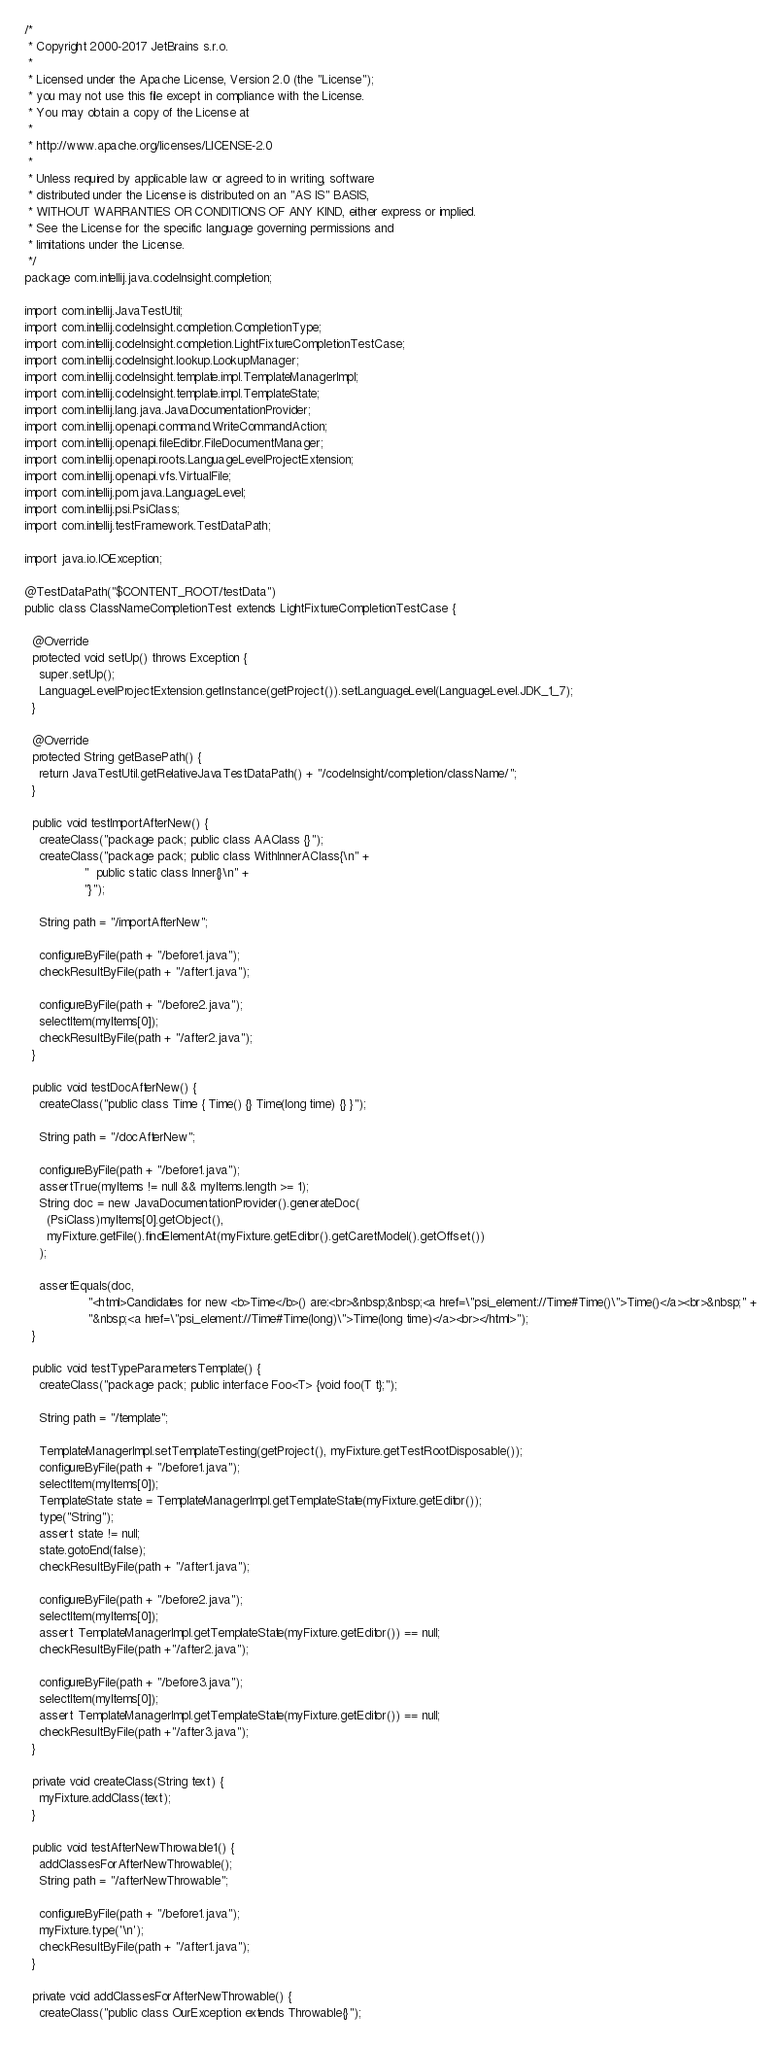<code> <loc_0><loc_0><loc_500><loc_500><_Java_>/*
 * Copyright 2000-2017 JetBrains s.r.o.
 *
 * Licensed under the Apache License, Version 2.0 (the "License");
 * you may not use this file except in compliance with the License.
 * You may obtain a copy of the License at
 *
 * http://www.apache.org/licenses/LICENSE-2.0
 *
 * Unless required by applicable law or agreed to in writing, software
 * distributed under the License is distributed on an "AS IS" BASIS,
 * WITHOUT WARRANTIES OR CONDITIONS OF ANY KIND, either express or implied.
 * See the License for the specific language governing permissions and
 * limitations under the License.
 */
package com.intellij.java.codeInsight.completion;

import com.intellij.JavaTestUtil;
import com.intellij.codeInsight.completion.CompletionType;
import com.intellij.codeInsight.completion.LightFixtureCompletionTestCase;
import com.intellij.codeInsight.lookup.LookupManager;
import com.intellij.codeInsight.template.impl.TemplateManagerImpl;
import com.intellij.codeInsight.template.impl.TemplateState;
import com.intellij.lang.java.JavaDocumentationProvider;
import com.intellij.openapi.command.WriteCommandAction;
import com.intellij.openapi.fileEditor.FileDocumentManager;
import com.intellij.openapi.roots.LanguageLevelProjectExtension;
import com.intellij.openapi.vfs.VirtualFile;
import com.intellij.pom.java.LanguageLevel;
import com.intellij.psi.PsiClass;
import com.intellij.testFramework.TestDataPath;

import java.io.IOException;

@TestDataPath("$CONTENT_ROOT/testData")
public class ClassNameCompletionTest extends LightFixtureCompletionTestCase {

  @Override
  protected void setUp() throws Exception {
    super.setUp();
    LanguageLevelProjectExtension.getInstance(getProject()).setLanguageLevel(LanguageLevel.JDK_1_7);
  }

  @Override
  protected String getBasePath() {
    return JavaTestUtil.getRelativeJavaTestDataPath() + "/codeInsight/completion/className/";
  }

  public void testImportAfterNew() {
    createClass("package pack; public class AAClass {}");
    createClass("package pack; public class WithInnerAClass{\n" +
                "  public static class Inner{}\n" +
                "}");

    String path = "/importAfterNew";

    configureByFile(path + "/before1.java");
    checkResultByFile(path + "/after1.java");

    configureByFile(path + "/before2.java");
    selectItem(myItems[0]);
    checkResultByFile(path + "/after2.java");
  }

  public void testDocAfterNew() {
    createClass("public class Time { Time() {} Time(long time) {} }");

    String path = "/docAfterNew";

    configureByFile(path + "/before1.java");
    assertTrue(myItems != null && myItems.length >= 1);
    String doc = new JavaDocumentationProvider().generateDoc(
      (PsiClass)myItems[0].getObject(),
      myFixture.getFile().findElementAt(myFixture.getEditor().getCaretModel().getOffset())
    );

    assertEquals(doc,
                 "<html>Candidates for new <b>Time</b>() are:<br>&nbsp;&nbsp;<a href=\"psi_element://Time#Time()\">Time()</a><br>&nbsp;" +
                 "&nbsp;<a href=\"psi_element://Time#Time(long)\">Time(long time)</a><br></html>");
  }

  public void testTypeParametersTemplate() {
    createClass("package pack; public interface Foo<T> {void foo(T t};");

    String path = "/template";

    TemplateManagerImpl.setTemplateTesting(getProject(), myFixture.getTestRootDisposable());
    configureByFile(path + "/before1.java");
    selectItem(myItems[0]);
    TemplateState state = TemplateManagerImpl.getTemplateState(myFixture.getEditor());
    type("String");
    assert state != null;
    state.gotoEnd(false);
    checkResultByFile(path + "/after1.java");

    configureByFile(path + "/before2.java");
    selectItem(myItems[0]);
    assert TemplateManagerImpl.getTemplateState(myFixture.getEditor()) == null;
    checkResultByFile(path +"/after2.java");

    configureByFile(path + "/before3.java");
    selectItem(myItems[0]);
    assert TemplateManagerImpl.getTemplateState(myFixture.getEditor()) == null;
    checkResultByFile(path +"/after3.java");
  }

  private void createClass(String text) {
    myFixture.addClass(text);
  }

  public void testAfterNewThrowable1() {
    addClassesForAfterNewThrowable();
    String path = "/afterNewThrowable";

    configureByFile(path + "/before1.java");
    myFixture.type('\n');
    checkResultByFile(path + "/after1.java");
  }

  private void addClassesForAfterNewThrowable() {
    createClass("public class OurException extends Throwable{}");</code> 